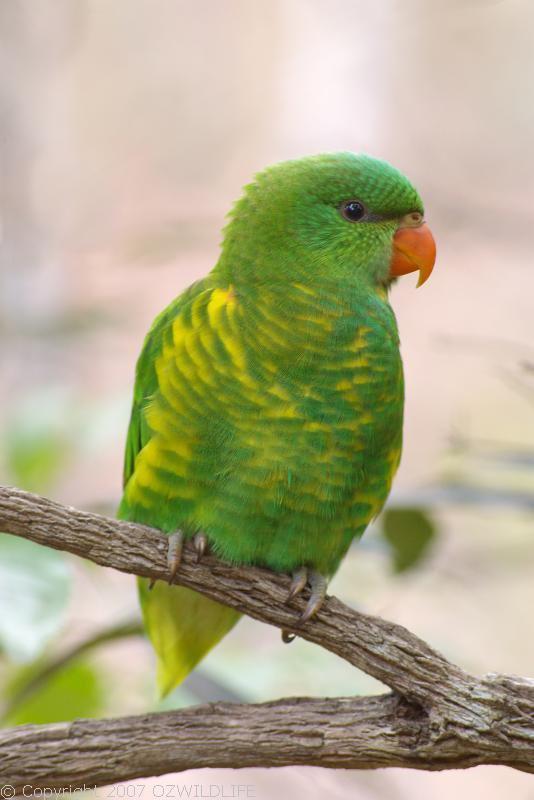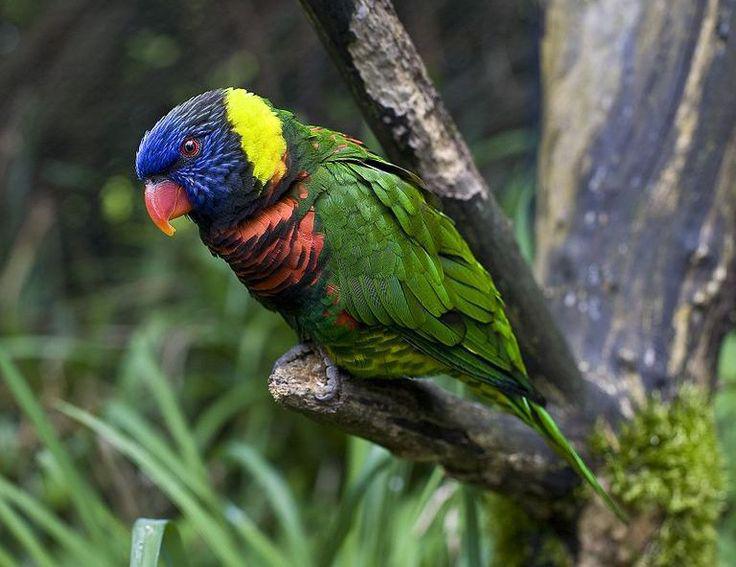The first image is the image on the left, the second image is the image on the right. Examine the images to the left and right. Is the description "Exactly two parrots are sitting on tree branches, both of them having at least some green on their bodies, but only one with a blue head." accurate? Answer yes or no. Yes. The first image is the image on the left, the second image is the image on the right. Analyze the images presented: Is the assertion "The left image shows exactly one parrot, and it is perched on a wooden limb." valid? Answer yes or no. Yes. 